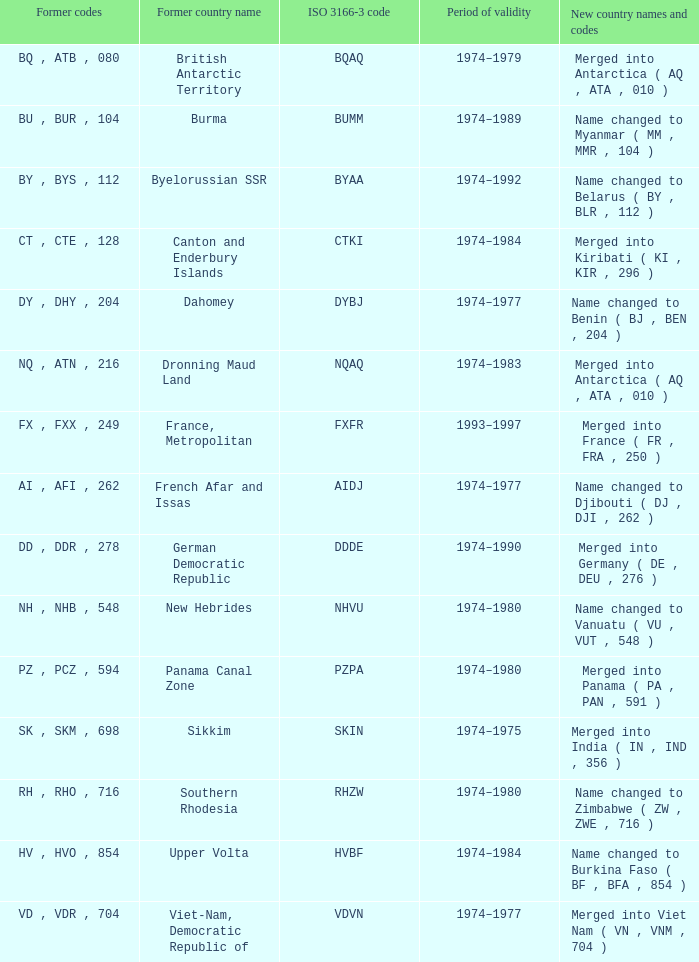Name the former codes for  merged into panama ( pa , pan , 591 ) PZ , PCZ , 594. Would you mind parsing the complete table? {'header': ['Former codes', 'Former country name', 'ISO 3166-3 code', 'Period of validity', 'New country names and codes'], 'rows': [['BQ , ATB , 080', 'British Antarctic Territory', 'BQAQ', '1974–1979', 'Merged into Antarctica ( AQ , ATA , 010 )'], ['BU , BUR , 104', 'Burma', 'BUMM', '1974–1989', 'Name changed to Myanmar ( MM , MMR , 104 )'], ['BY , BYS , 112', 'Byelorussian SSR', 'BYAA', '1974–1992', 'Name changed to Belarus ( BY , BLR , 112 )'], ['CT , CTE , 128', 'Canton and Enderbury Islands', 'CTKI', '1974–1984', 'Merged into Kiribati ( KI , KIR , 296 )'], ['DY , DHY , 204', 'Dahomey', 'DYBJ', '1974–1977', 'Name changed to Benin ( BJ , BEN , 204 )'], ['NQ , ATN , 216', 'Dronning Maud Land', 'NQAQ', '1974–1983', 'Merged into Antarctica ( AQ , ATA , 010 )'], ['FX , FXX , 249', 'France, Metropolitan', 'FXFR', '1993–1997', 'Merged into France ( FR , FRA , 250 )'], ['AI , AFI , 262', 'French Afar and Issas', 'AIDJ', '1974–1977', 'Name changed to Djibouti ( DJ , DJI , 262 )'], ['DD , DDR , 278', 'German Democratic Republic', 'DDDE', '1974–1990', 'Merged into Germany ( DE , DEU , 276 )'], ['NH , NHB , 548', 'New Hebrides', 'NHVU', '1974–1980', 'Name changed to Vanuatu ( VU , VUT , 548 )'], ['PZ , PCZ , 594', 'Panama Canal Zone', 'PZPA', '1974–1980', 'Merged into Panama ( PA , PAN , 591 )'], ['SK , SKM , 698', 'Sikkim', 'SKIN', '1974–1975', 'Merged into India ( IN , IND , 356 )'], ['RH , RHO , 716', 'Southern Rhodesia', 'RHZW', '1974–1980', 'Name changed to Zimbabwe ( ZW , ZWE , 716 )'], ['HV , HVO , 854', 'Upper Volta', 'HVBF', '1974–1984', 'Name changed to Burkina Faso ( BF , BFA , 854 )'], ['VD , VDR , 704', 'Viet-Nam, Democratic Republic of', 'VDVN', '1974–1977', 'Merged into Viet Nam ( VN , VNM , 704 )']]} 